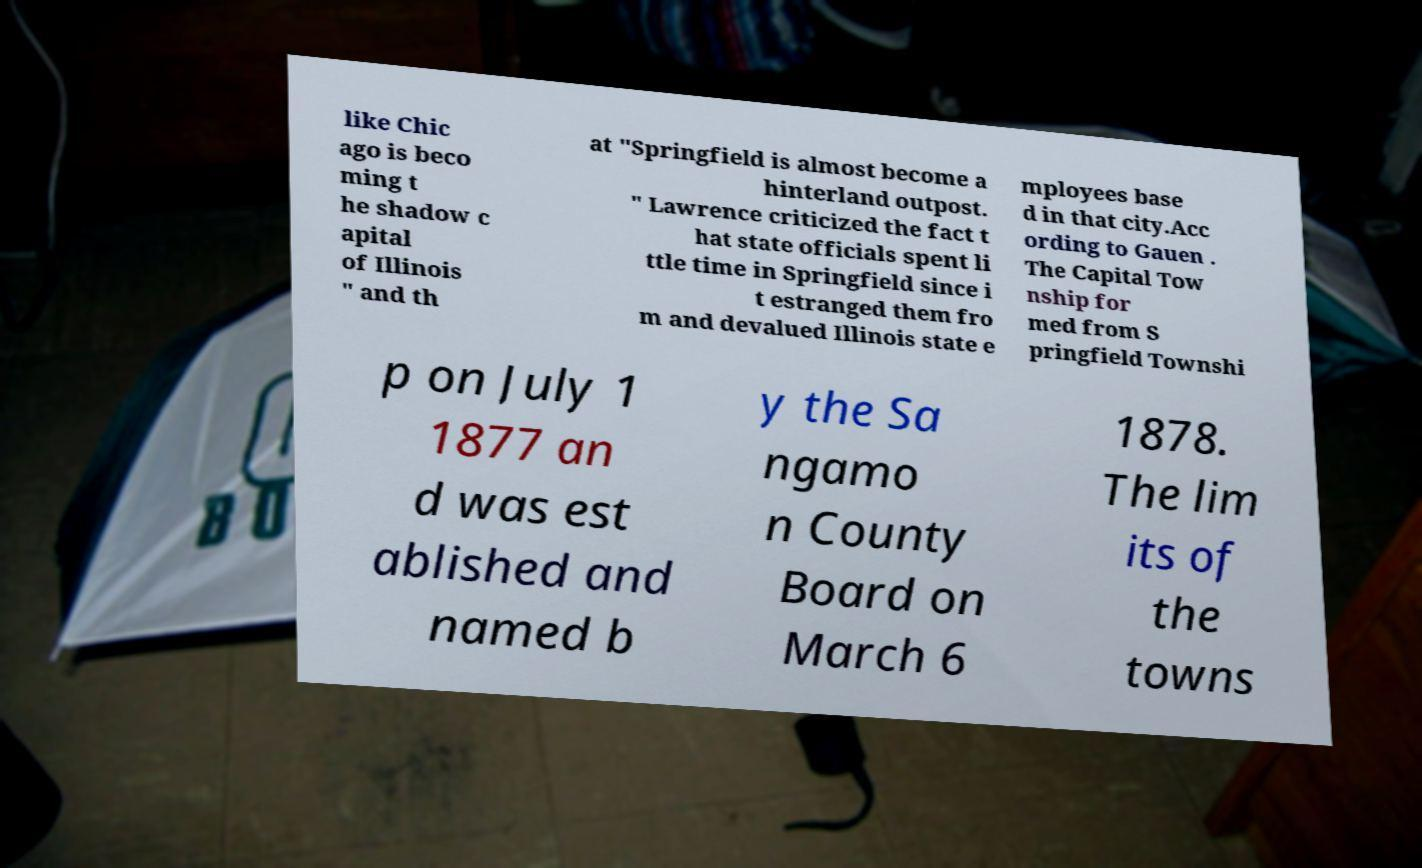Please read and relay the text visible in this image. What does it say? like Chic ago is beco ming t he shadow c apital of Illinois " and th at "Springfield is almost become a hinterland outpost. " Lawrence criticized the fact t hat state officials spent li ttle time in Springfield since i t estranged them fro m and devalued Illinois state e mployees base d in that city.Acc ording to Gauen . The Capital Tow nship for med from S pringfield Townshi p on July 1 1877 an d was est ablished and named b y the Sa ngamo n County Board on March 6 1878. The lim its of the towns 